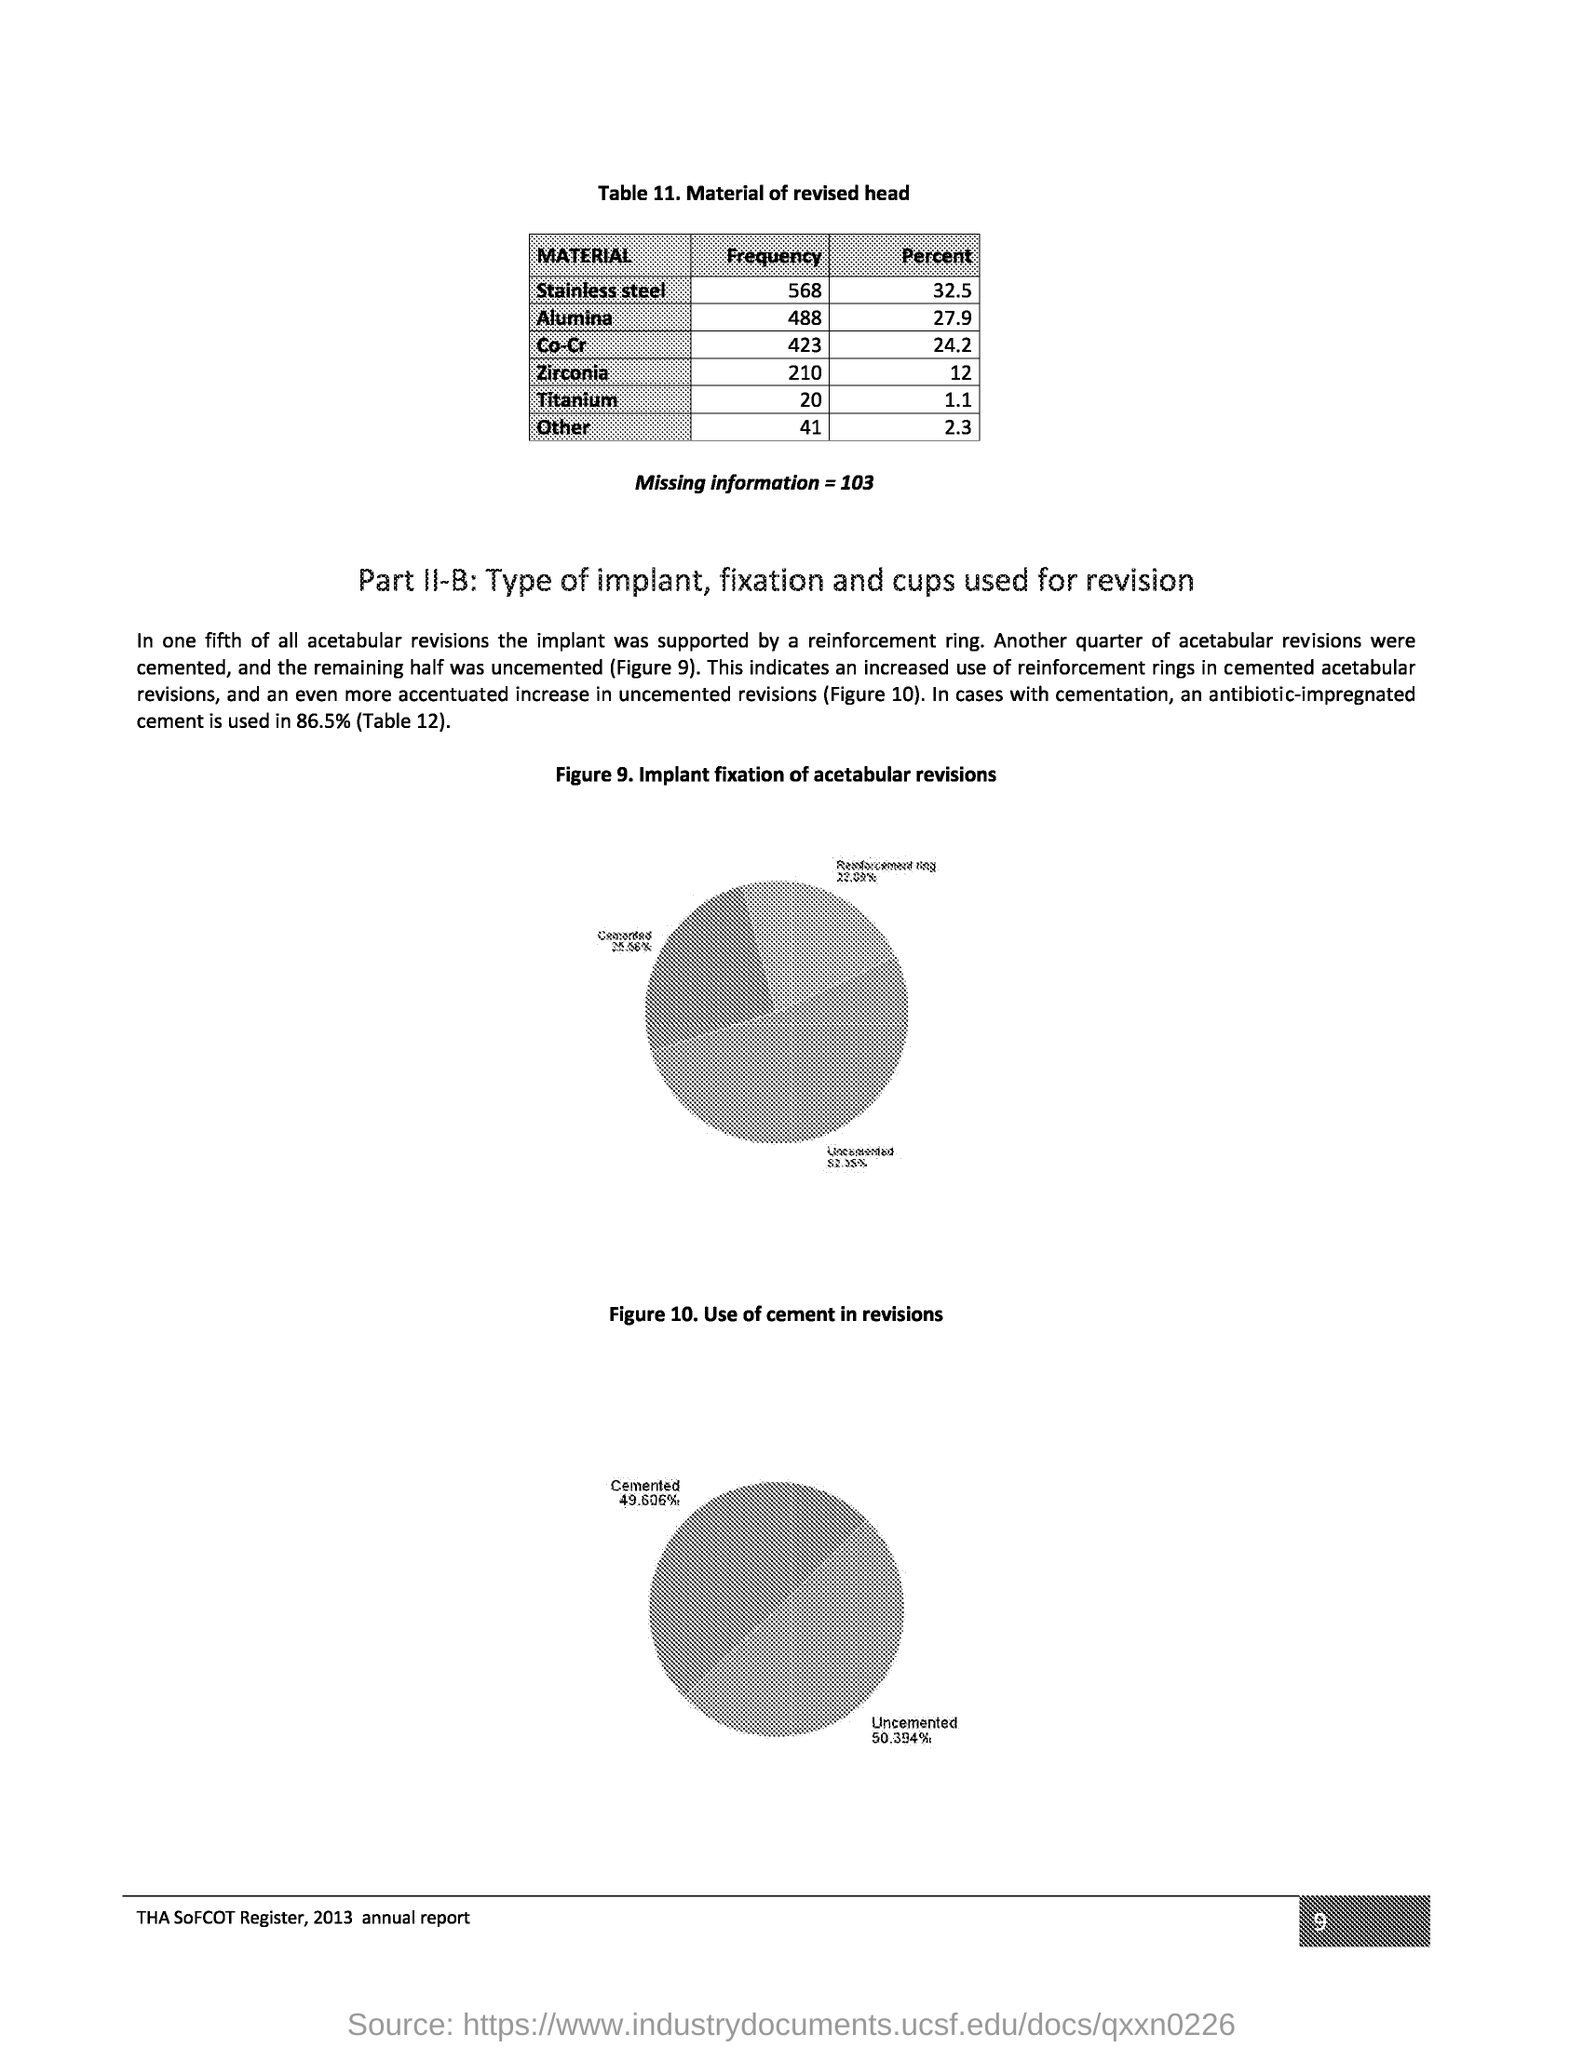Mention a couple of crucial points in this snapshot. I, at page number 9, declare that... In approximately 20% of acetabular revisions, the implant was supported by a reinforcement ring. The title of Figure 9 is 'Implant Fixation of Acetabular Revisions.' The frequency of stainless steel is 568. The heading of Table 11 is 'Revised Material'. 